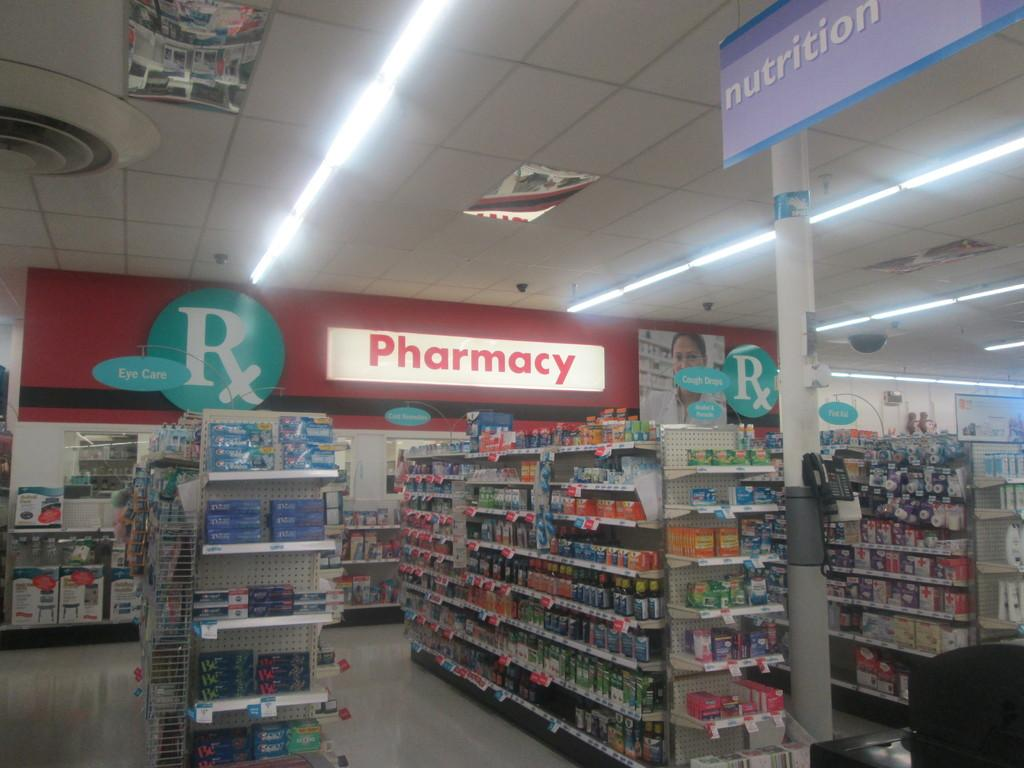What can be seen on the racks in the image? The facts do not specify what is on the racks, so we cannot answer this question definitively. Where is the telephone located in the image? The telephone is on a pole in the image. What is the large sign in the image called? The large sign is called a hoarding in the image. What can be seen providing illumination in the image? There are lights in the image. What type of cake is being advertised on the hoarding in the image? There is no cake being advertised on the hoarding in the image; it is a large sign with unspecified content. What caption is written on the hoarding in the image? The facts do not provide information about any captions on the hoarding, so we cannot answer this question definitively. 